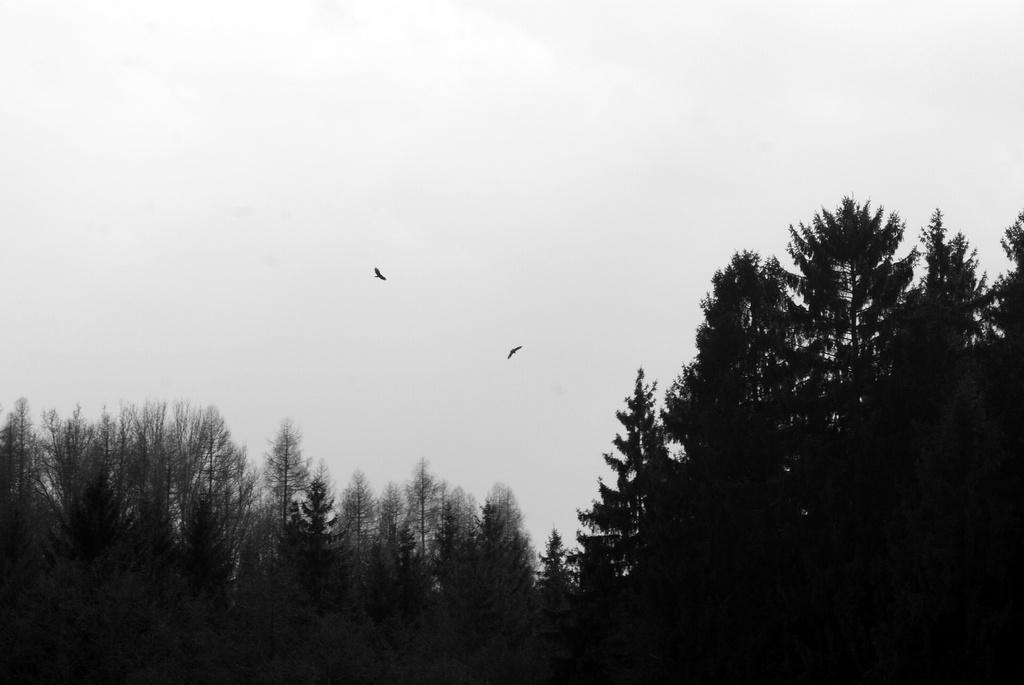What type of vegetation is present in the image? There are trees in the image. What can be seen in the sky in the background of the image? There are birds flying in the sky in the background of the image. What type of parent is depicted in the image? There is no parent depicted in the image; it features trees and birds flying in the sky. What type of fork can be seen in the image? There is no fork present in the image. 